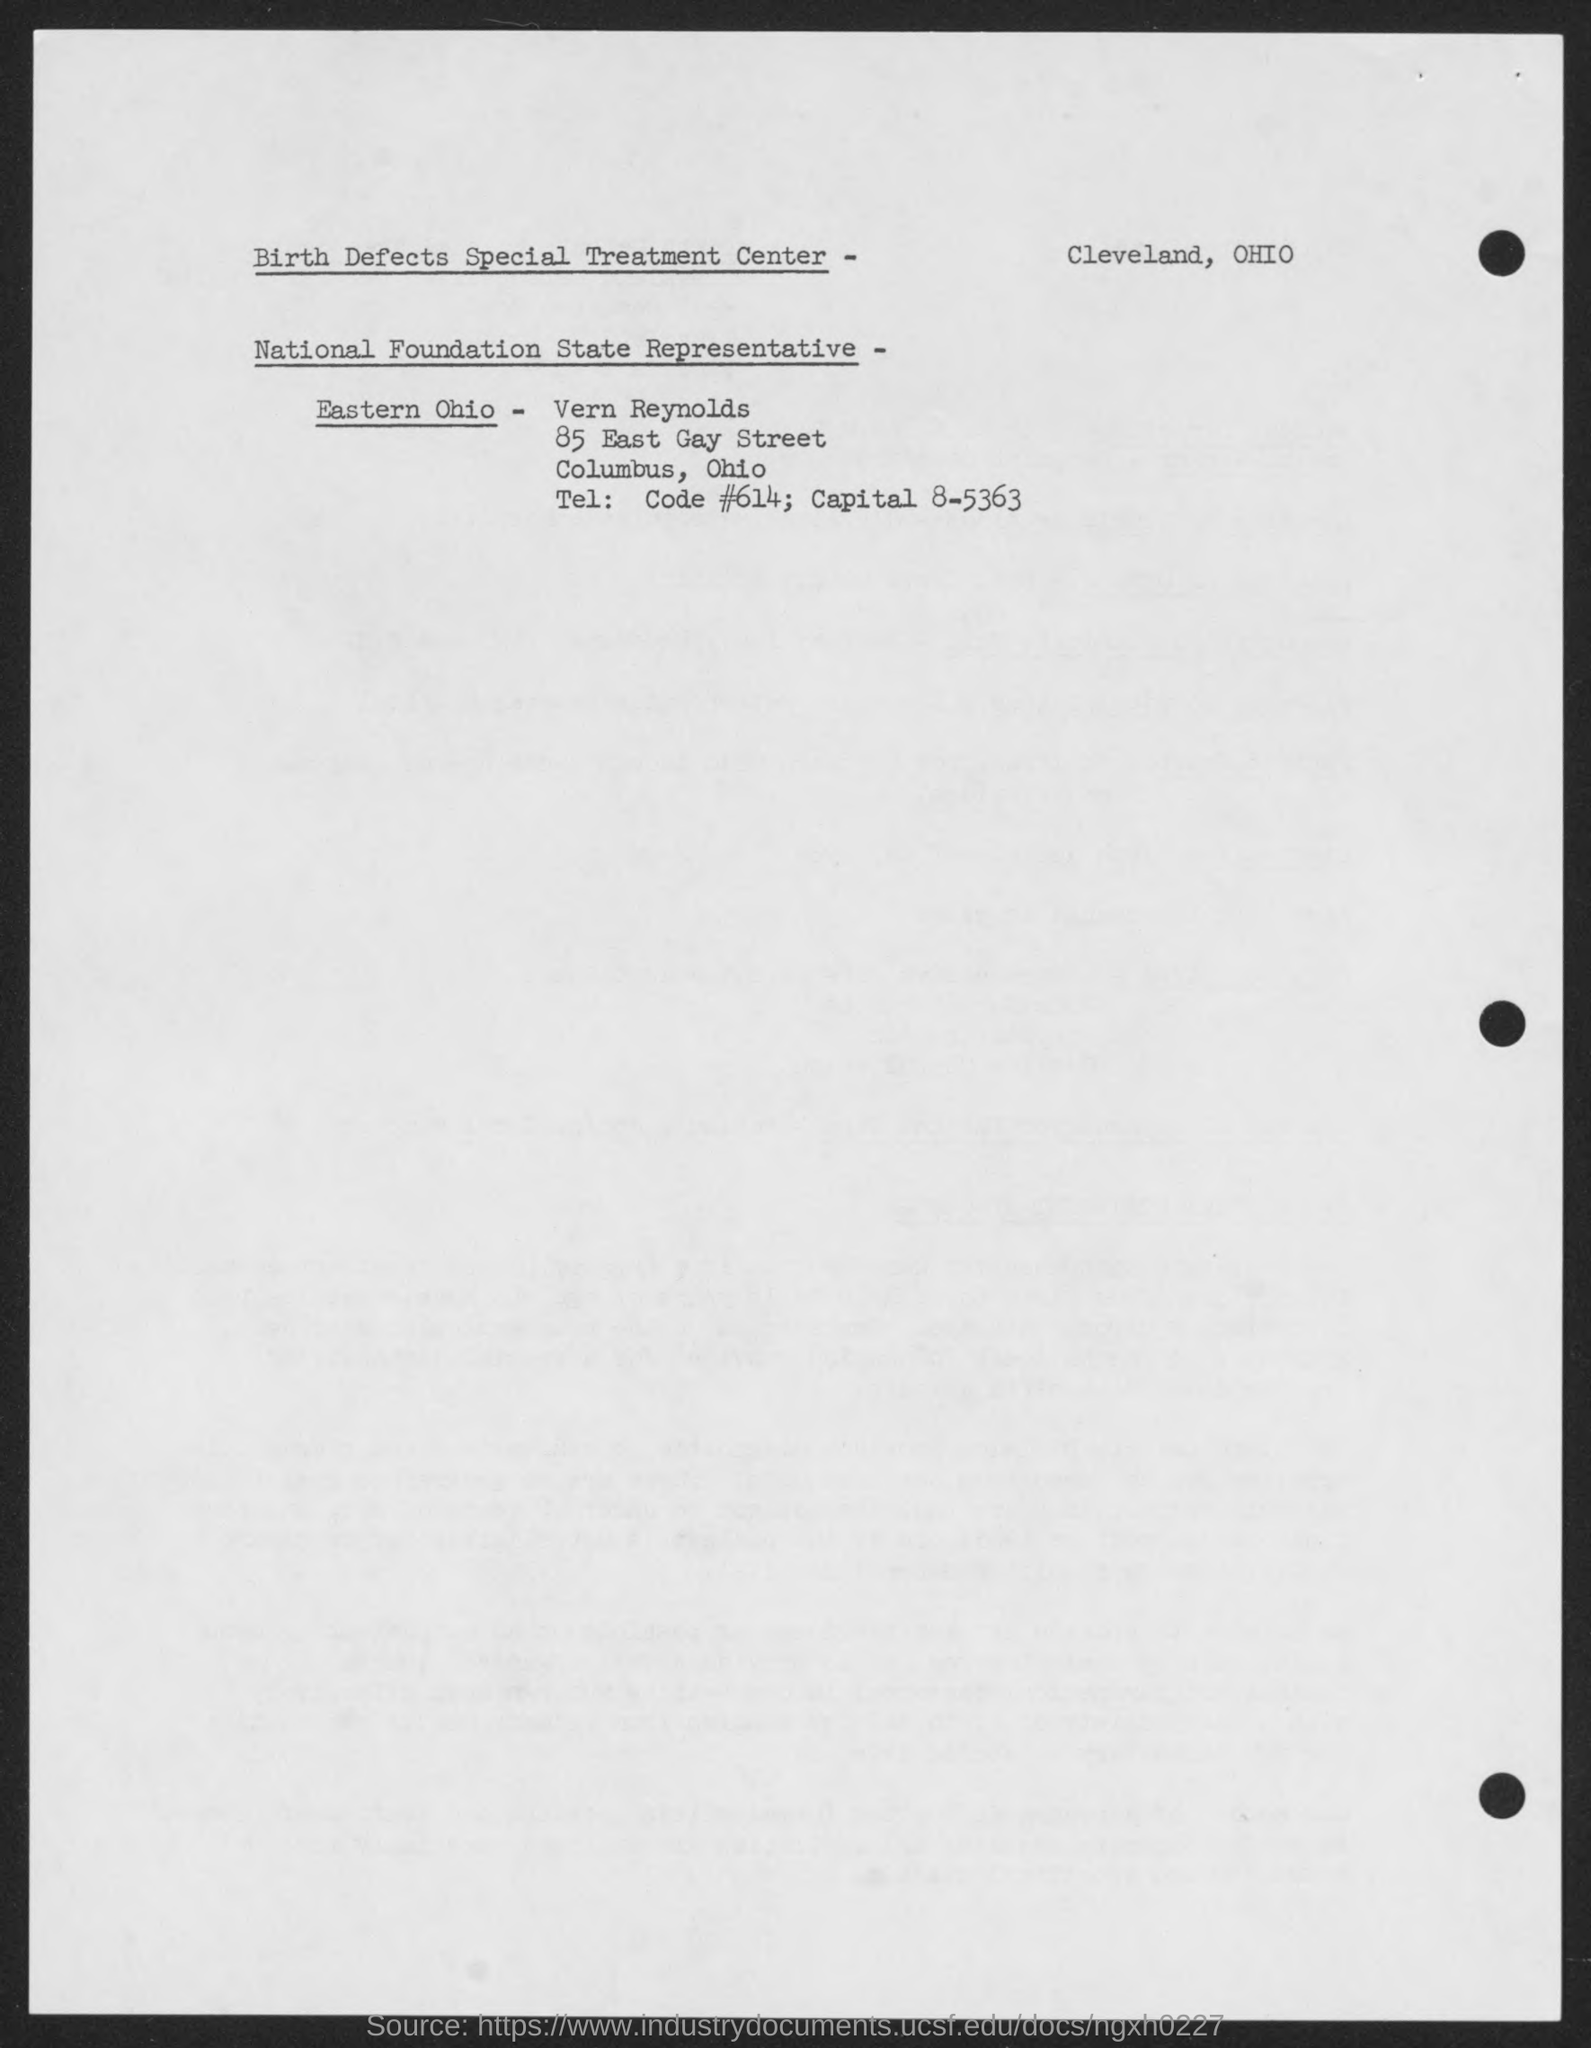Indicate a few pertinent items in this graphic. The National Foundation State Representative-Eastern Ohio is Vern Reynolds. 